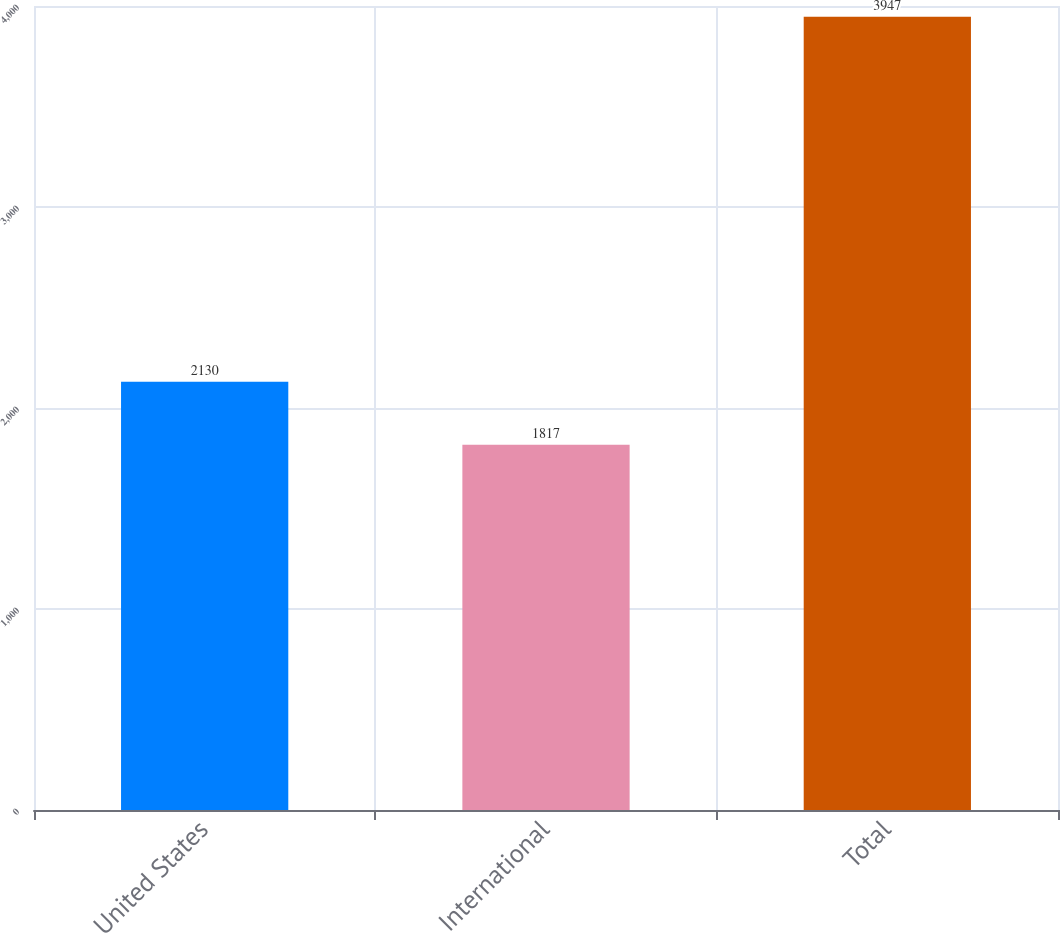<chart> <loc_0><loc_0><loc_500><loc_500><bar_chart><fcel>United States<fcel>International<fcel>Total<nl><fcel>2130<fcel>1817<fcel>3947<nl></chart> 